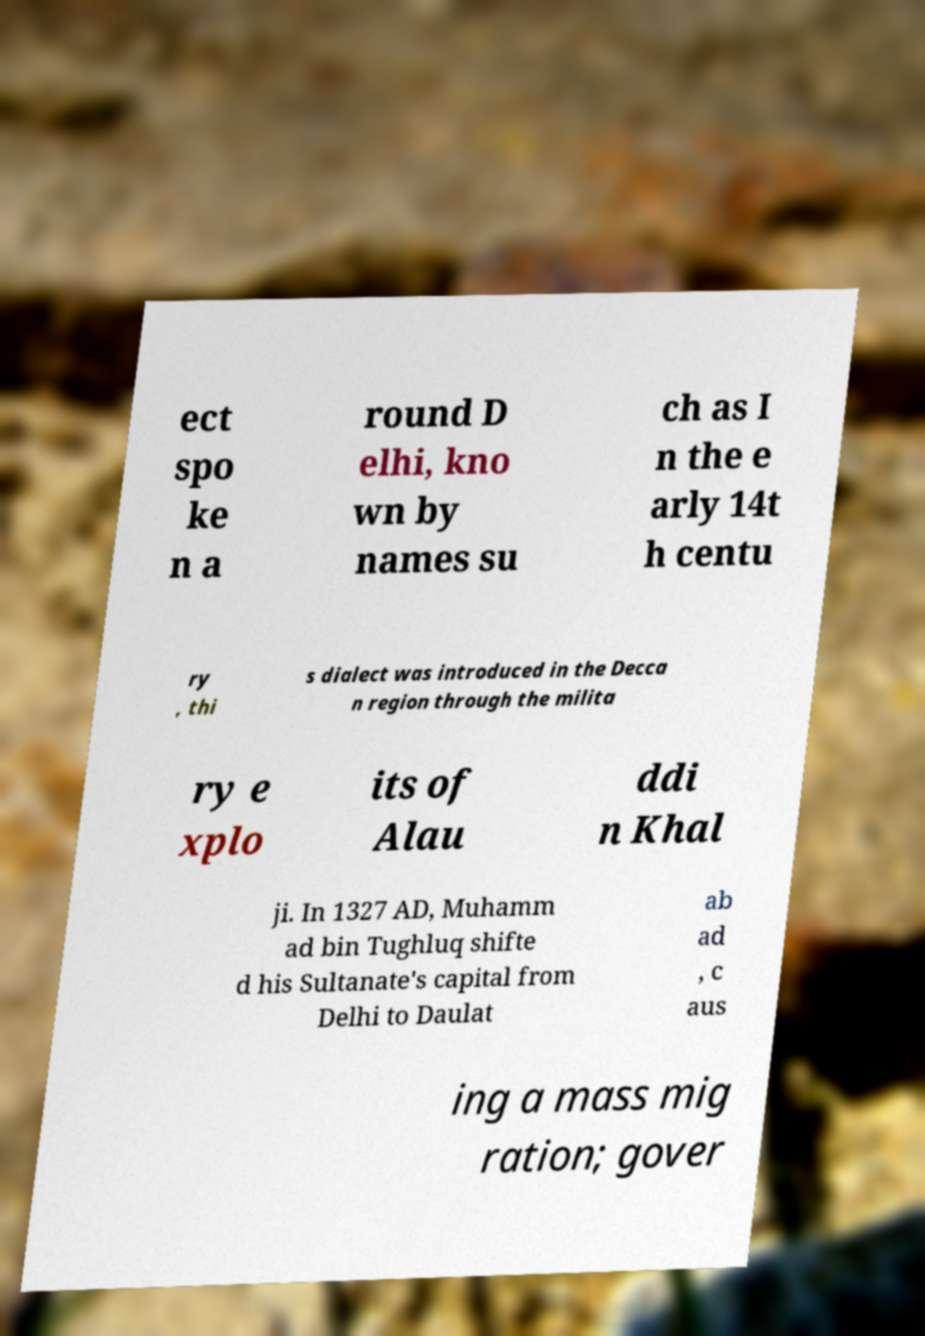Could you extract and type out the text from this image? ect spo ke n a round D elhi, kno wn by names su ch as I n the e arly 14t h centu ry , thi s dialect was introduced in the Decca n region through the milita ry e xplo its of Alau ddi n Khal ji. In 1327 AD, Muhamm ad bin Tughluq shifte d his Sultanate's capital from Delhi to Daulat ab ad , c aus ing a mass mig ration; gover 